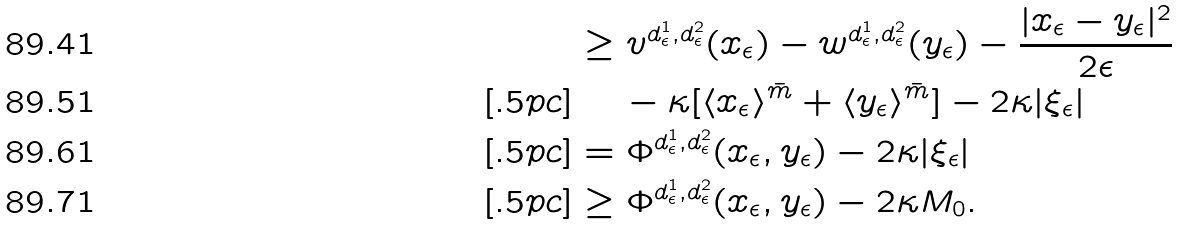Convert formula to latex. <formula><loc_0><loc_0><loc_500><loc_500>& \geq v ^ { d _ { \epsilon } ^ { 1 } , d _ { \epsilon } ^ { 2 } } ( x _ { \epsilon } ) - w ^ { d _ { \epsilon } ^ { 1 } , d _ { \epsilon } ^ { 2 } } ( y _ { \epsilon } ) - \frac { | x _ { \epsilon } - y _ { \epsilon } | ^ { 2 } } { 2 \epsilon } \\ [ . 5 p c ] & \quad \, - \kappa [ \langle x _ { \epsilon } \rangle ^ { \bar { m } } + \langle y _ { \epsilon } \rangle ^ { \bar { m } } ] - 2 \kappa | \xi _ { \epsilon } | \\ [ . 5 p c ] & = \Phi ^ { d ^ { 1 } _ { \epsilon } , d ^ { 2 } _ { \epsilon } } ( x _ { \epsilon } , y _ { \epsilon } ) - 2 \kappa | \xi _ { \epsilon } | \\ [ . 5 p c ] & \geq \Phi ^ { d ^ { 1 } _ { \epsilon } , d ^ { 2 } _ { \epsilon } } ( x _ { \epsilon } , y _ { \epsilon } ) - 2 \kappa M _ { 0 } .</formula> 